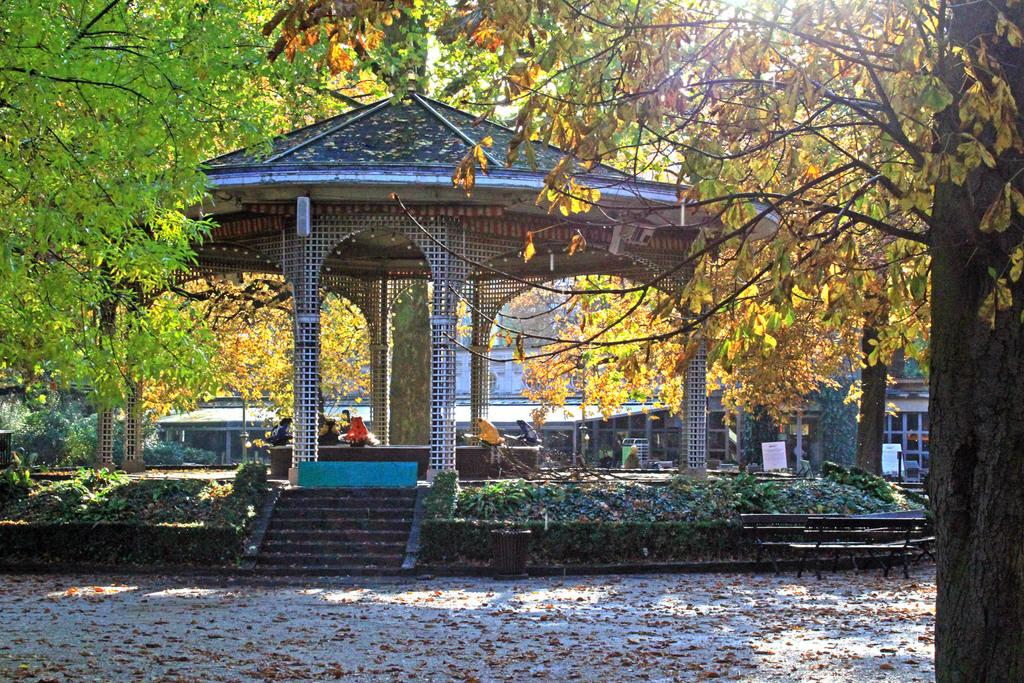What structure is the main focus of the image? There is a gazebo in the image. What type of natural elements surround the gazebo? There are trees around the gazebo. What can be seen behind the trees in the image? There is a building behind the trees. How many deer are visible in the image? There are no deer present in the image. What type of property does the gazebo belong to? The image does not provide information about the property ownership or type. 